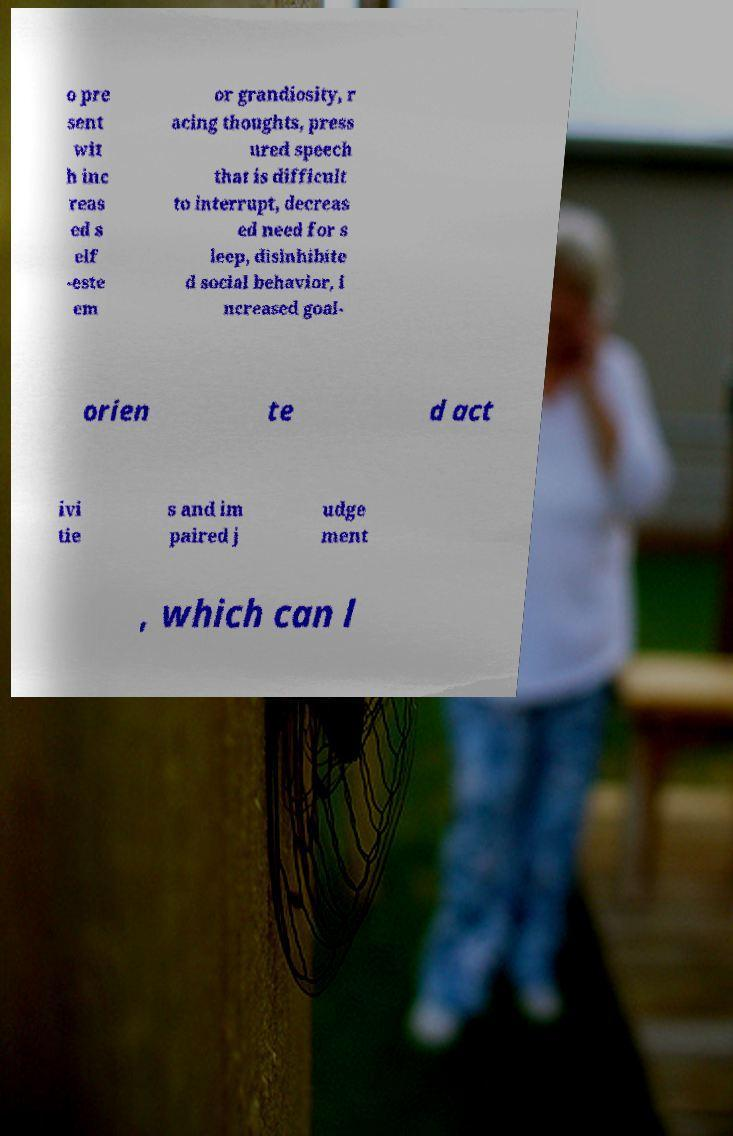Please read and relay the text visible in this image. What does it say? o pre sent wit h inc reas ed s elf -este em or grandiosity, r acing thoughts, press ured speech that is difficult to interrupt, decreas ed need for s leep, disinhibite d social behavior, i ncreased goal- orien te d act ivi tie s and im paired j udge ment , which can l 